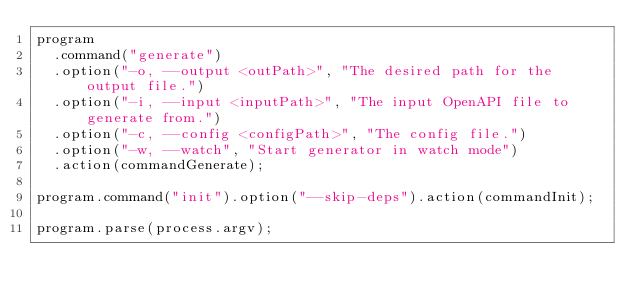<code> <loc_0><loc_0><loc_500><loc_500><_TypeScript_>program
  .command("generate")
  .option("-o, --output <outPath>", "The desired path for the output file.")
  .option("-i, --input <inputPath>", "The input OpenAPI file to generate from.")
  .option("-c, --config <configPath>", "The config file.")
  .option("-w, --watch", "Start generator in watch mode")
  .action(commandGenerate);

program.command("init").option("--skip-deps").action(commandInit);

program.parse(process.argv);
</code> 